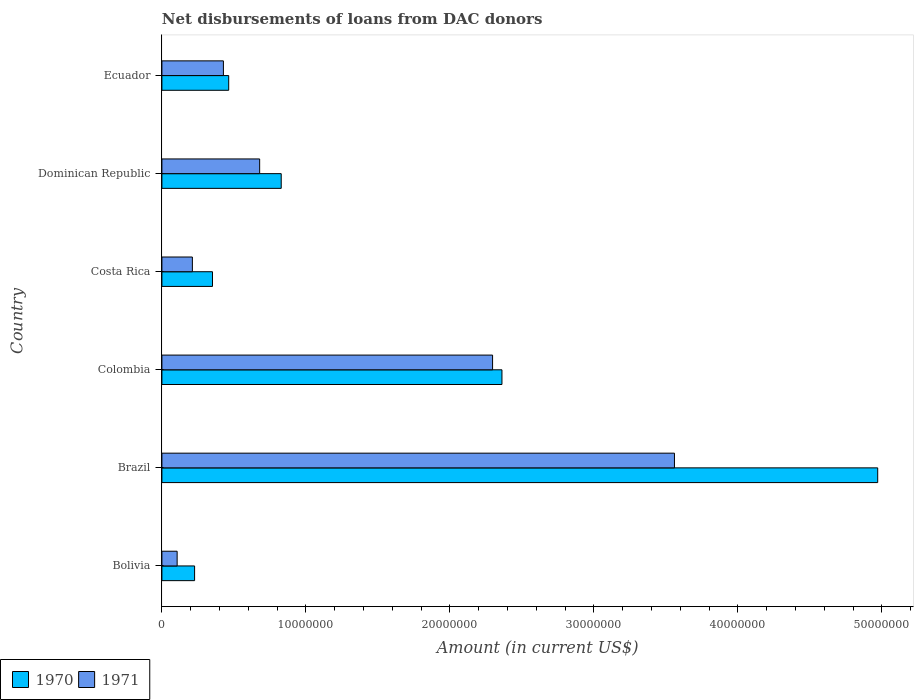How many groups of bars are there?
Your answer should be very brief. 6. Are the number of bars per tick equal to the number of legend labels?
Provide a short and direct response. Yes. Are the number of bars on each tick of the Y-axis equal?
Your answer should be very brief. Yes. What is the label of the 4th group of bars from the top?
Offer a terse response. Colombia. What is the amount of loans disbursed in 1970 in Costa Rica?
Give a very brief answer. 3.51e+06. Across all countries, what is the maximum amount of loans disbursed in 1971?
Provide a short and direct response. 3.56e+07. Across all countries, what is the minimum amount of loans disbursed in 1971?
Offer a terse response. 1.06e+06. In which country was the amount of loans disbursed in 1971 maximum?
Your answer should be very brief. Brazil. What is the total amount of loans disbursed in 1971 in the graph?
Make the answer very short. 7.28e+07. What is the difference between the amount of loans disbursed in 1971 in Colombia and that in Costa Rica?
Offer a terse response. 2.08e+07. What is the difference between the amount of loans disbursed in 1971 in Brazil and the amount of loans disbursed in 1970 in Bolivia?
Offer a very short reply. 3.33e+07. What is the average amount of loans disbursed in 1970 per country?
Your answer should be very brief. 1.53e+07. What is the difference between the amount of loans disbursed in 1970 and amount of loans disbursed in 1971 in Dominican Republic?
Provide a short and direct response. 1.50e+06. In how many countries, is the amount of loans disbursed in 1970 greater than 38000000 US$?
Offer a terse response. 1. What is the ratio of the amount of loans disbursed in 1971 in Bolivia to that in Colombia?
Offer a very short reply. 0.05. Is the amount of loans disbursed in 1970 in Colombia less than that in Ecuador?
Keep it short and to the point. No. Is the difference between the amount of loans disbursed in 1970 in Bolivia and Colombia greater than the difference between the amount of loans disbursed in 1971 in Bolivia and Colombia?
Keep it short and to the point. Yes. What is the difference between the highest and the second highest amount of loans disbursed in 1971?
Give a very brief answer. 1.26e+07. What is the difference between the highest and the lowest amount of loans disbursed in 1971?
Make the answer very short. 3.45e+07. In how many countries, is the amount of loans disbursed in 1971 greater than the average amount of loans disbursed in 1971 taken over all countries?
Keep it short and to the point. 2. Is the sum of the amount of loans disbursed in 1971 in Bolivia and Dominican Republic greater than the maximum amount of loans disbursed in 1970 across all countries?
Offer a very short reply. No. What does the 2nd bar from the bottom in Costa Rica represents?
Make the answer very short. 1971. How many bars are there?
Give a very brief answer. 12. How many countries are there in the graph?
Provide a short and direct response. 6. What is the difference between two consecutive major ticks on the X-axis?
Ensure brevity in your answer.  1.00e+07. Where does the legend appear in the graph?
Your answer should be compact. Bottom left. How many legend labels are there?
Your answer should be compact. 2. What is the title of the graph?
Give a very brief answer. Net disbursements of loans from DAC donors. Does "2002" appear as one of the legend labels in the graph?
Make the answer very short. No. What is the label or title of the X-axis?
Your answer should be very brief. Amount (in current US$). What is the Amount (in current US$) of 1970 in Bolivia?
Give a very brief answer. 2.27e+06. What is the Amount (in current US$) of 1971 in Bolivia?
Make the answer very short. 1.06e+06. What is the Amount (in current US$) in 1970 in Brazil?
Your answer should be very brief. 4.97e+07. What is the Amount (in current US$) of 1971 in Brazil?
Provide a succinct answer. 3.56e+07. What is the Amount (in current US$) in 1970 in Colombia?
Your answer should be very brief. 2.36e+07. What is the Amount (in current US$) of 1971 in Colombia?
Offer a terse response. 2.30e+07. What is the Amount (in current US$) of 1970 in Costa Rica?
Your response must be concise. 3.51e+06. What is the Amount (in current US$) of 1971 in Costa Rica?
Your answer should be very brief. 2.12e+06. What is the Amount (in current US$) in 1970 in Dominican Republic?
Ensure brevity in your answer.  8.29e+06. What is the Amount (in current US$) in 1971 in Dominican Republic?
Your answer should be very brief. 6.79e+06. What is the Amount (in current US$) of 1970 in Ecuador?
Your answer should be compact. 4.64e+06. What is the Amount (in current US$) in 1971 in Ecuador?
Give a very brief answer. 4.27e+06. Across all countries, what is the maximum Amount (in current US$) of 1970?
Provide a succinct answer. 4.97e+07. Across all countries, what is the maximum Amount (in current US$) in 1971?
Provide a succinct answer. 3.56e+07. Across all countries, what is the minimum Amount (in current US$) of 1970?
Your response must be concise. 2.27e+06. Across all countries, what is the minimum Amount (in current US$) of 1971?
Make the answer very short. 1.06e+06. What is the total Amount (in current US$) of 1970 in the graph?
Make the answer very short. 9.20e+07. What is the total Amount (in current US$) in 1971 in the graph?
Give a very brief answer. 7.28e+07. What is the difference between the Amount (in current US$) of 1970 in Bolivia and that in Brazil?
Provide a succinct answer. -4.74e+07. What is the difference between the Amount (in current US$) of 1971 in Bolivia and that in Brazil?
Provide a succinct answer. -3.45e+07. What is the difference between the Amount (in current US$) in 1970 in Bolivia and that in Colombia?
Make the answer very short. -2.13e+07. What is the difference between the Amount (in current US$) of 1971 in Bolivia and that in Colombia?
Give a very brief answer. -2.19e+07. What is the difference between the Amount (in current US$) of 1970 in Bolivia and that in Costa Rica?
Your answer should be compact. -1.24e+06. What is the difference between the Amount (in current US$) in 1971 in Bolivia and that in Costa Rica?
Provide a short and direct response. -1.06e+06. What is the difference between the Amount (in current US$) of 1970 in Bolivia and that in Dominican Republic?
Provide a succinct answer. -6.02e+06. What is the difference between the Amount (in current US$) of 1971 in Bolivia and that in Dominican Republic?
Give a very brief answer. -5.73e+06. What is the difference between the Amount (in current US$) of 1970 in Bolivia and that in Ecuador?
Your answer should be very brief. -2.37e+06. What is the difference between the Amount (in current US$) in 1971 in Bolivia and that in Ecuador?
Your answer should be very brief. -3.21e+06. What is the difference between the Amount (in current US$) in 1970 in Brazil and that in Colombia?
Give a very brief answer. 2.61e+07. What is the difference between the Amount (in current US$) of 1971 in Brazil and that in Colombia?
Keep it short and to the point. 1.26e+07. What is the difference between the Amount (in current US$) in 1970 in Brazil and that in Costa Rica?
Ensure brevity in your answer.  4.62e+07. What is the difference between the Amount (in current US$) in 1971 in Brazil and that in Costa Rica?
Your answer should be compact. 3.35e+07. What is the difference between the Amount (in current US$) in 1970 in Brazil and that in Dominican Republic?
Provide a short and direct response. 4.14e+07. What is the difference between the Amount (in current US$) of 1971 in Brazil and that in Dominican Republic?
Offer a very short reply. 2.88e+07. What is the difference between the Amount (in current US$) in 1970 in Brazil and that in Ecuador?
Your response must be concise. 4.51e+07. What is the difference between the Amount (in current US$) of 1971 in Brazil and that in Ecuador?
Offer a very short reply. 3.13e+07. What is the difference between the Amount (in current US$) of 1970 in Colombia and that in Costa Rica?
Offer a terse response. 2.01e+07. What is the difference between the Amount (in current US$) of 1971 in Colombia and that in Costa Rica?
Ensure brevity in your answer.  2.08e+07. What is the difference between the Amount (in current US$) in 1970 in Colombia and that in Dominican Republic?
Keep it short and to the point. 1.53e+07. What is the difference between the Amount (in current US$) of 1971 in Colombia and that in Dominican Republic?
Give a very brief answer. 1.62e+07. What is the difference between the Amount (in current US$) in 1970 in Colombia and that in Ecuador?
Your answer should be compact. 1.90e+07. What is the difference between the Amount (in current US$) of 1971 in Colombia and that in Ecuador?
Give a very brief answer. 1.87e+07. What is the difference between the Amount (in current US$) in 1970 in Costa Rica and that in Dominican Republic?
Keep it short and to the point. -4.77e+06. What is the difference between the Amount (in current US$) of 1971 in Costa Rica and that in Dominican Republic?
Your response must be concise. -4.67e+06. What is the difference between the Amount (in current US$) in 1970 in Costa Rica and that in Ecuador?
Offer a terse response. -1.13e+06. What is the difference between the Amount (in current US$) of 1971 in Costa Rica and that in Ecuador?
Give a very brief answer. -2.16e+06. What is the difference between the Amount (in current US$) of 1970 in Dominican Republic and that in Ecuador?
Your answer should be very brief. 3.65e+06. What is the difference between the Amount (in current US$) of 1971 in Dominican Republic and that in Ecuador?
Ensure brevity in your answer.  2.52e+06. What is the difference between the Amount (in current US$) of 1970 in Bolivia and the Amount (in current US$) of 1971 in Brazil?
Your answer should be compact. -3.33e+07. What is the difference between the Amount (in current US$) in 1970 in Bolivia and the Amount (in current US$) in 1971 in Colombia?
Ensure brevity in your answer.  -2.07e+07. What is the difference between the Amount (in current US$) in 1970 in Bolivia and the Amount (in current US$) in 1971 in Costa Rica?
Your answer should be compact. 1.54e+05. What is the difference between the Amount (in current US$) in 1970 in Bolivia and the Amount (in current US$) in 1971 in Dominican Republic?
Provide a succinct answer. -4.52e+06. What is the difference between the Amount (in current US$) in 1970 in Bolivia and the Amount (in current US$) in 1971 in Ecuador?
Your answer should be compact. -2.00e+06. What is the difference between the Amount (in current US$) of 1970 in Brazil and the Amount (in current US$) of 1971 in Colombia?
Give a very brief answer. 2.67e+07. What is the difference between the Amount (in current US$) of 1970 in Brazil and the Amount (in current US$) of 1971 in Costa Rica?
Your response must be concise. 4.76e+07. What is the difference between the Amount (in current US$) in 1970 in Brazil and the Amount (in current US$) in 1971 in Dominican Republic?
Provide a short and direct response. 4.29e+07. What is the difference between the Amount (in current US$) of 1970 in Brazil and the Amount (in current US$) of 1971 in Ecuador?
Give a very brief answer. 4.54e+07. What is the difference between the Amount (in current US$) in 1970 in Colombia and the Amount (in current US$) in 1971 in Costa Rica?
Provide a succinct answer. 2.15e+07. What is the difference between the Amount (in current US$) in 1970 in Colombia and the Amount (in current US$) in 1971 in Dominican Republic?
Make the answer very short. 1.68e+07. What is the difference between the Amount (in current US$) in 1970 in Colombia and the Amount (in current US$) in 1971 in Ecuador?
Offer a very short reply. 1.93e+07. What is the difference between the Amount (in current US$) of 1970 in Costa Rica and the Amount (in current US$) of 1971 in Dominican Republic?
Keep it short and to the point. -3.28e+06. What is the difference between the Amount (in current US$) in 1970 in Costa Rica and the Amount (in current US$) in 1971 in Ecuador?
Your response must be concise. -7.58e+05. What is the difference between the Amount (in current US$) in 1970 in Dominican Republic and the Amount (in current US$) in 1971 in Ecuador?
Your response must be concise. 4.02e+06. What is the average Amount (in current US$) in 1970 per country?
Offer a very short reply. 1.53e+07. What is the average Amount (in current US$) of 1971 per country?
Provide a short and direct response. 1.21e+07. What is the difference between the Amount (in current US$) of 1970 and Amount (in current US$) of 1971 in Bolivia?
Your answer should be very brief. 1.21e+06. What is the difference between the Amount (in current US$) in 1970 and Amount (in current US$) in 1971 in Brazil?
Keep it short and to the point. 1.41e+07. What is the difference between the Amount (in current US$) of 1970 and Amount (in current US$) of 1971 in Colombia?
Offer a terse response. 6.52e+05. What is the difference between the Amount (in current US$) of 1970 and Amount (in current US$) of 1971 in Costa Rica?
Your answer should be compact. 1.40e+06. What is the difference between the Amount (in current US$) of 1970 and Amount (in current US$) of 1971 in Dominican Republic?
Provide a short and direct response. 1.50e+06. What is the difference between the Amount (in current US$) of 1970 and Amount (in current US$) of 1971 in Ecuador?
Offer a very short reply. 3.68e+05. What is the ratio of the Amount (in current US$) in 1970 in Bolivia to that in Brazil?
Make the answer very short. 0.05. What is the ratio of the Amount (in current US$) in 1971 in Bolivia to that in Brazil?
Your answer should be very brief. 0.03. What is the ratio of the Amount (in current US$) in 1970 in Bolivia to that in Colombia?
Ensure brevity in your answer.  0.1. What is the ratio of the Amount (in current US$) in 1971 in Bolivia to that in Colombia?
Offer a very short reply. 0.05. What is the ratio of the Amount (in current US$) in 1970 in Bolivia to that in Costa Rica?
Provide a short and direct response. 0.65. What is the ratio of the Amount (in current US$) in 1970 in Bolivia to that in Dominican Republic?
Give a very brief answer. 0.27. What is the ratio of the Amount (in current US$) of 1971 in Bolivia to that in Dominican Republic?
Provide a short and direct response. 0.16. What is the ratio of the Amount (in current US$) in 1970 in Bolivia to that in Ecuador?
Make the answer very short. 0.49. What is the ratio of the Amount (in current US$) in 1971 in Bolivia to that in Ecuador?
Your answer should be very brief. 0.25. What is the ratio of the Amount (in current US$) in 1970 in Brazil to that in Colombia?
Offer a terse response. 2.1. What is the ratio of the Amount (in current US$) of 1971 in Brazil to that in Colombia?
Give a very brief answer. 1.55. What is the ratio of the Amount (in current US$) of 1970 in Brazil to that in Costa Rica?
Keep it short and to the point. 14.15. What is the ratio of the Amount (in current US$) in 1971 in Brazil to that in Costa Rica?
Offer a very short reply. 16.82. What is the ratio of the Amount (in current US$) in 1970 in Brazil to that in Dominican Republic?
Offer a very short reply. 6. What is the ratio of the Amount (in current US$) in 1971 in Brazil to that in Dominican Republic?
Make the answer very short. 5.24. What is the ratio of the Amount (in current US$) in 1970 in Brazil to that in Ecuador?
Keep it short and to the point. 10.72. What is the ratio of the Amount (in current US$) of 1971 in Brazil to that in Ecuador?
Provide a succinct answer. 8.33. What is the ratio of the Amount (in current US$) of 1970 in Colombia to that in Costa Rica?
Make the answer very short. 6.72. What is the ratio of the Amount (in current US$) in 1971 in Colombia to that in Costa Rica?
Ensure brevity in your answer.  10.85. What is the ratio of the Amount (in current US$) of 1970 in Colombia to that in Dominican Republic?
Make the answer very short. 2.85. What is the ratio of the Amount (in current US$) in 1971 in Colombia to that in Dominican Republic?
Provide a short and direct response. 3.38. What is the ratio of the Amount (in current US$) of 1970 in Colombia to that in Ecuador?
Ensure brevity in your answer.  5.09. What is the ratio of the Amount (in current US$) in 1971 in Colombia to that in Ecuador?
Ensure brevity in your answer.  5.38. What is the ratio of the Amount (in current US$) in 1970 in Costa Rica to that in Dominican Republic?
Your response must be concise. 0.42. What is the ratio of the Amount (in current US$) in 1971 in Costa Rica to that in Dominican Republic?
Offer a very short reply. 0.31. What is the ratio of the Amount (in current US$) of 1970 in Costa Rica to that in Ecuador?
Keep it short and to the point. 0.76. What is the ratio of the Amount (in current US$) of 1971 in Costa Rica to that in Ecuador?
Make the answer very short. 0.5. What is the ratio of the Amount (in current US$) in 1970 in Dominican Republic to that in Ecuador?
Provide a short and direct response. 1.79. What is the ratio of the Amount (in current US$) of 1971 in Dominican Republic to that in Ecuador?
Provide a short and direct response. 1.59. What is the difference between the highest and the second highest Amount (in current US$) of 1970?
Offer a terse response. 2.61e+07. What is the difference between the highest and the second highest Amount (in current US$) in 1971?
Your answer should be very brief. 1.26e+07. What is the difference between the highest and the lowest Amount (in current US$) in 1970?
Provide a succinct answer. 4.74e+07. What is the difference between the highest and the lowest Amount (in current US$) in 1971?
Give a very brief answer. 3.45e+07. 